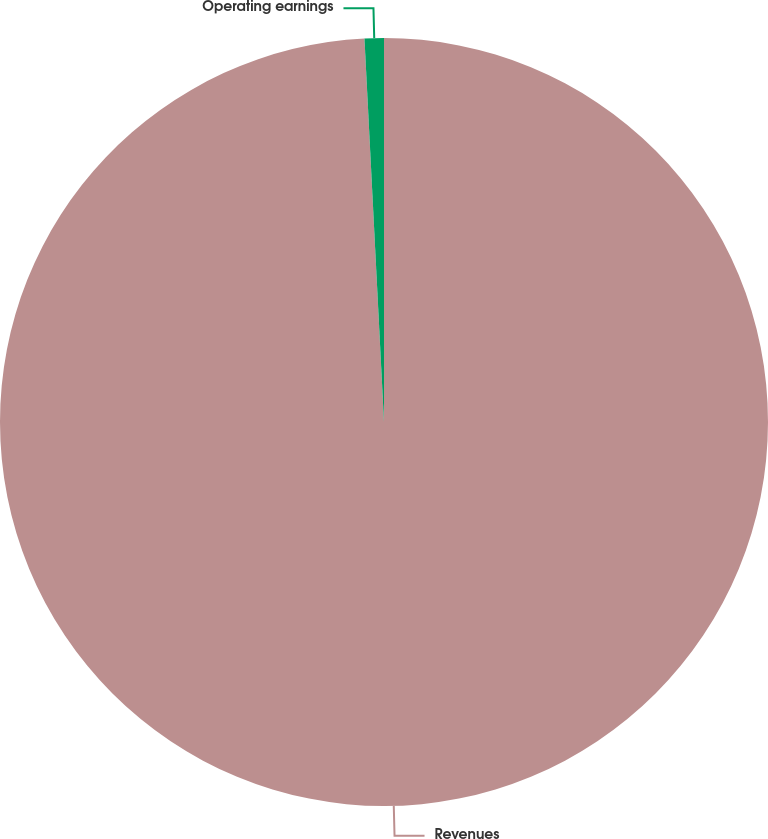<chart> <loc_0><loc_0><loc_500><loc_500><pie_chart><fcel>Revenues<fcel>Operating earnings<nl><fcel>99.19%<fcel>0.81%<nl></chart> 